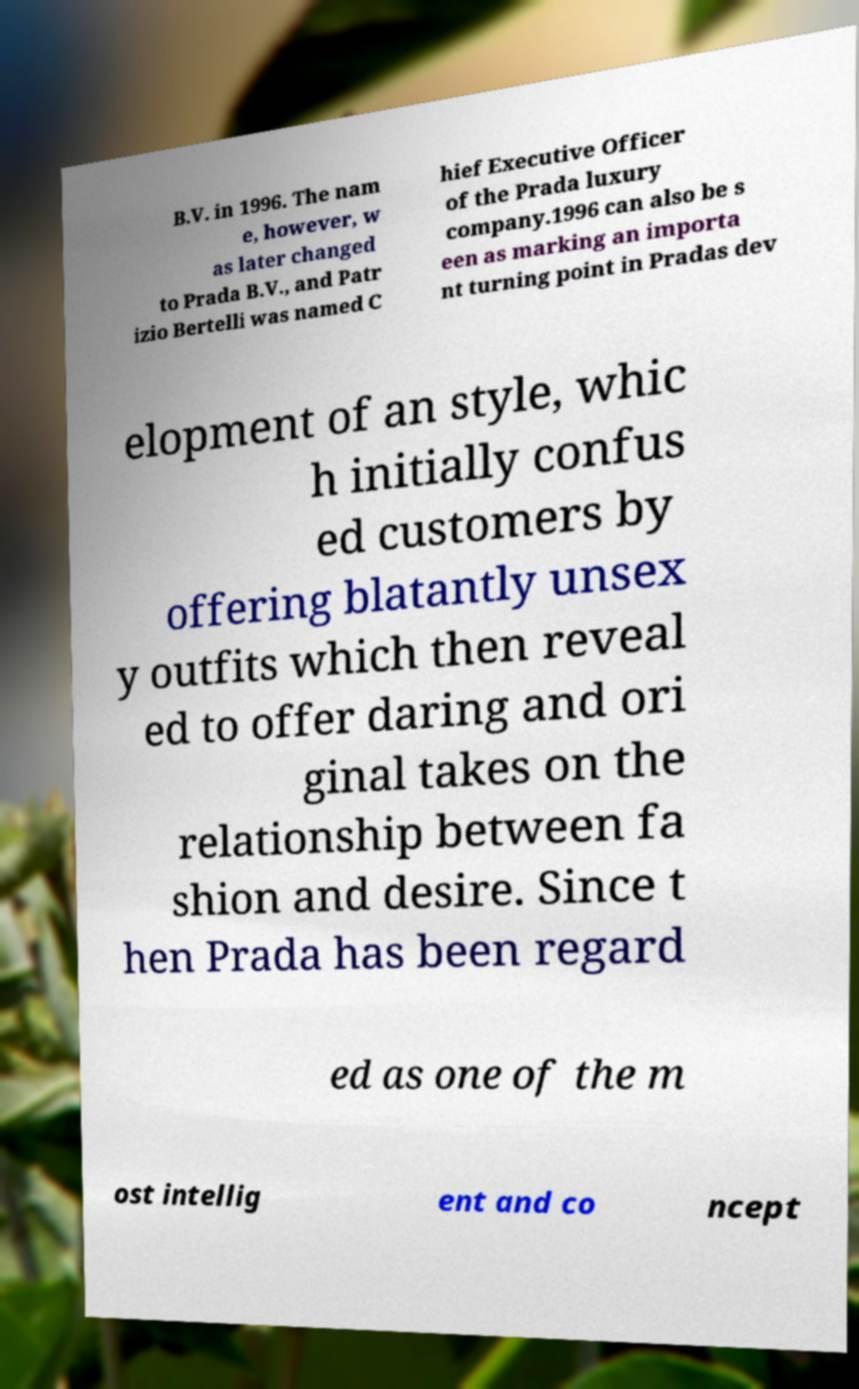What messages or text are displayed in this image? I need them in a readable, typed format. B.V. in 1996. The nam e, however, w as later changed to Prada B.V., and Patr izio Bertelli was named C hief Executive Officer of the Prada luxury company.1996 can also be s een as marking an importa nt turning point in Pradas dev elopment of an style, whic h initially confus ed customers by offering blatantly unsex y outfits which then reveal ed to offer daring and ori ginal takes on the relationship between fa shion and desire. Since t hen Prada has been regard ed as one of the m ost intellig ent and co ncept 